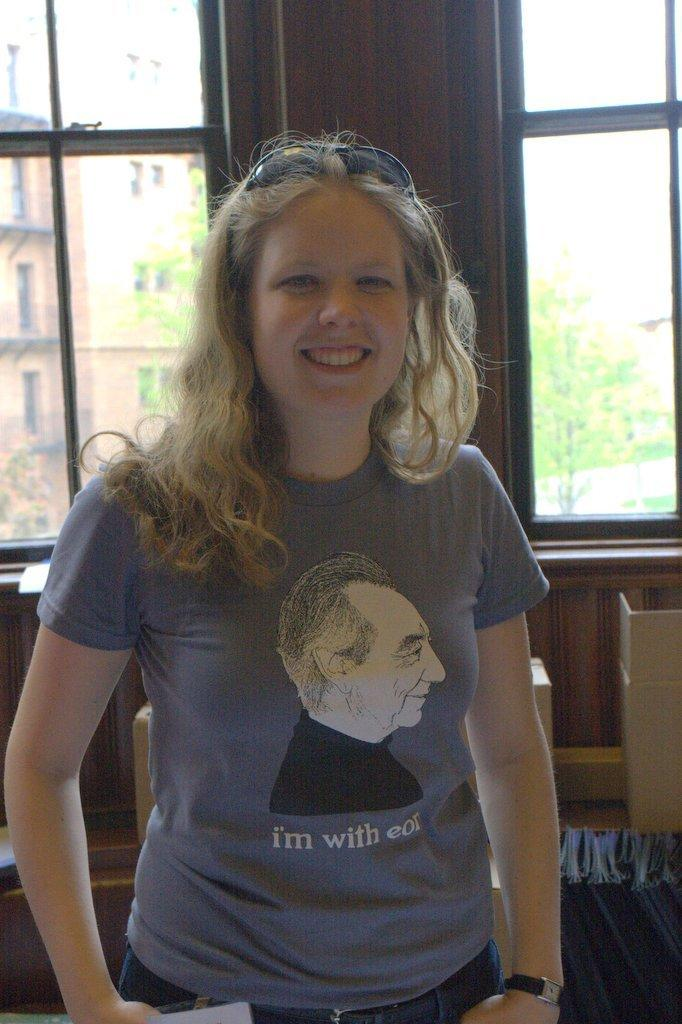What is the primary subject in the image? There is a woman standing in the image. What can be seen in the background of the image? There are windows, a wall, and objects on the floor in the background of the image. What is visible through the window glass? Buildings, trees, and the sky are visible through the window glass. How many babies are sitting on the goat's legs in the image? There are no babies, goat, or legs of a goat present in the image. 